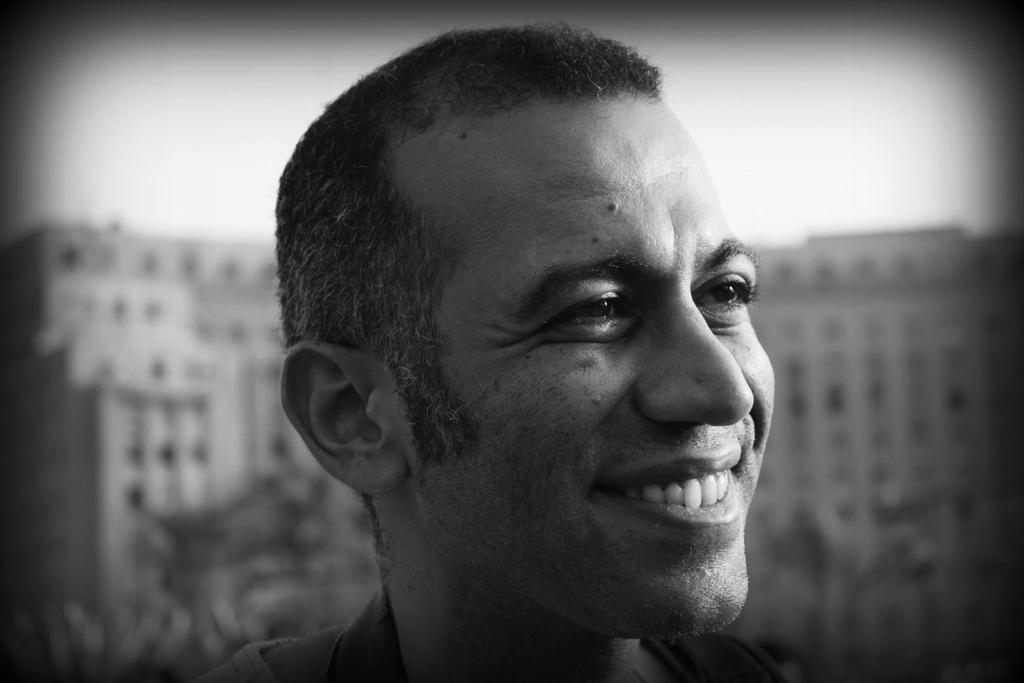What is the main subject in the foreground of the image? There is a man's face in the foreground of the image. What expression does the man have? The man is smiling. What is the color scheme of the image? The image is in black and white. What can be seen in the background of the image? There is a building in the background of the image. What is visible at the top of the image? The sky is visible at the top of the image. What type of celery is being used to show respect in the image? There is no celery present in the image, and respect is not being demonstrated through any object or action. How does the man's expression reflect his views on society in the image? The image does not provide any information about the man's views on society, and his expression is simply a smile. 